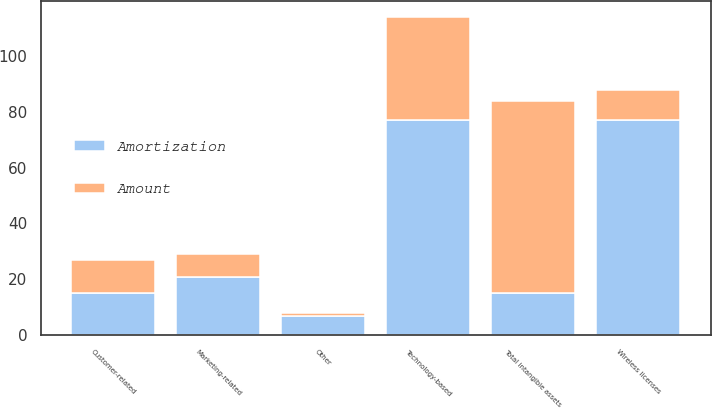<chart> <loc_0><loc_0><loc_500><loc_500><stacked_bar_chart><ecel><fcel>Wireless licenses<fcel>Marketing-related<fcel>Technology-based<fcel>Customer-related<fcel>Other<fcel>Total intangible assets<nl><fcel>Amortization<fcel>77<fcel>21<fcel>77<fcel>15<fcel>7<fcel>15<nl><fcel>Amount<fcel>11<fcel>8<fcel>37<fcel>12<fcel>1<fcel>69<nl></chart> 